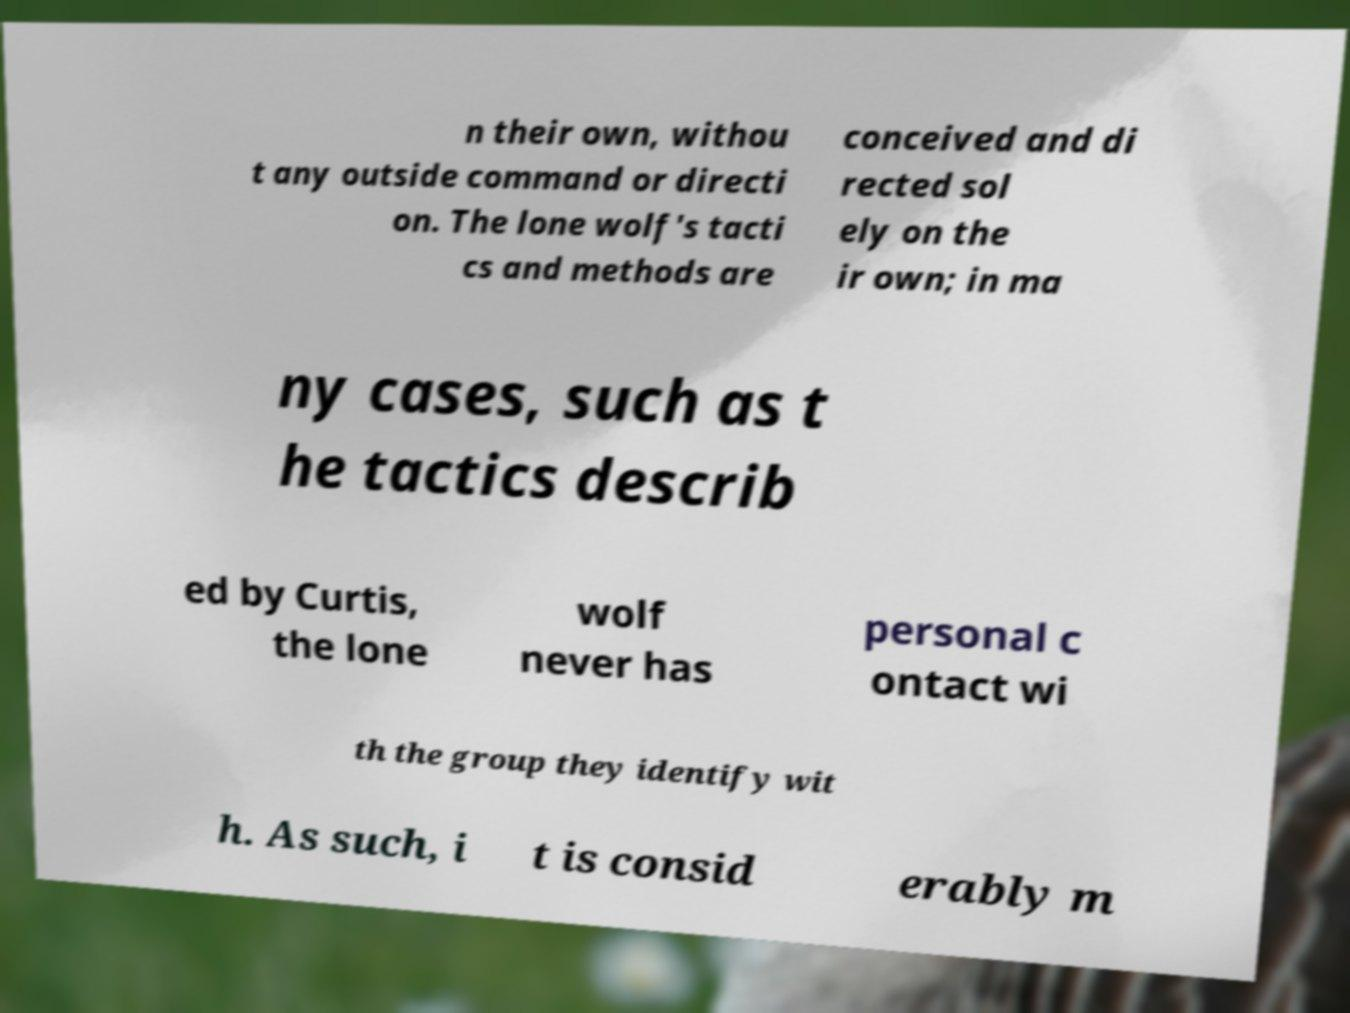What messages or text are displayed in this image? I need them in a readable, typed format. n their own, withou t any outside command or directi on. The lone wolf's tacti cs and methods are conceived and di rected sol ely on the ir own; in ma ny cases, such as t he tactics describ ed by Curtis, the lone wolf never has personal c ontact wi th the group they identify wit h. As such, i t is consid erably m 